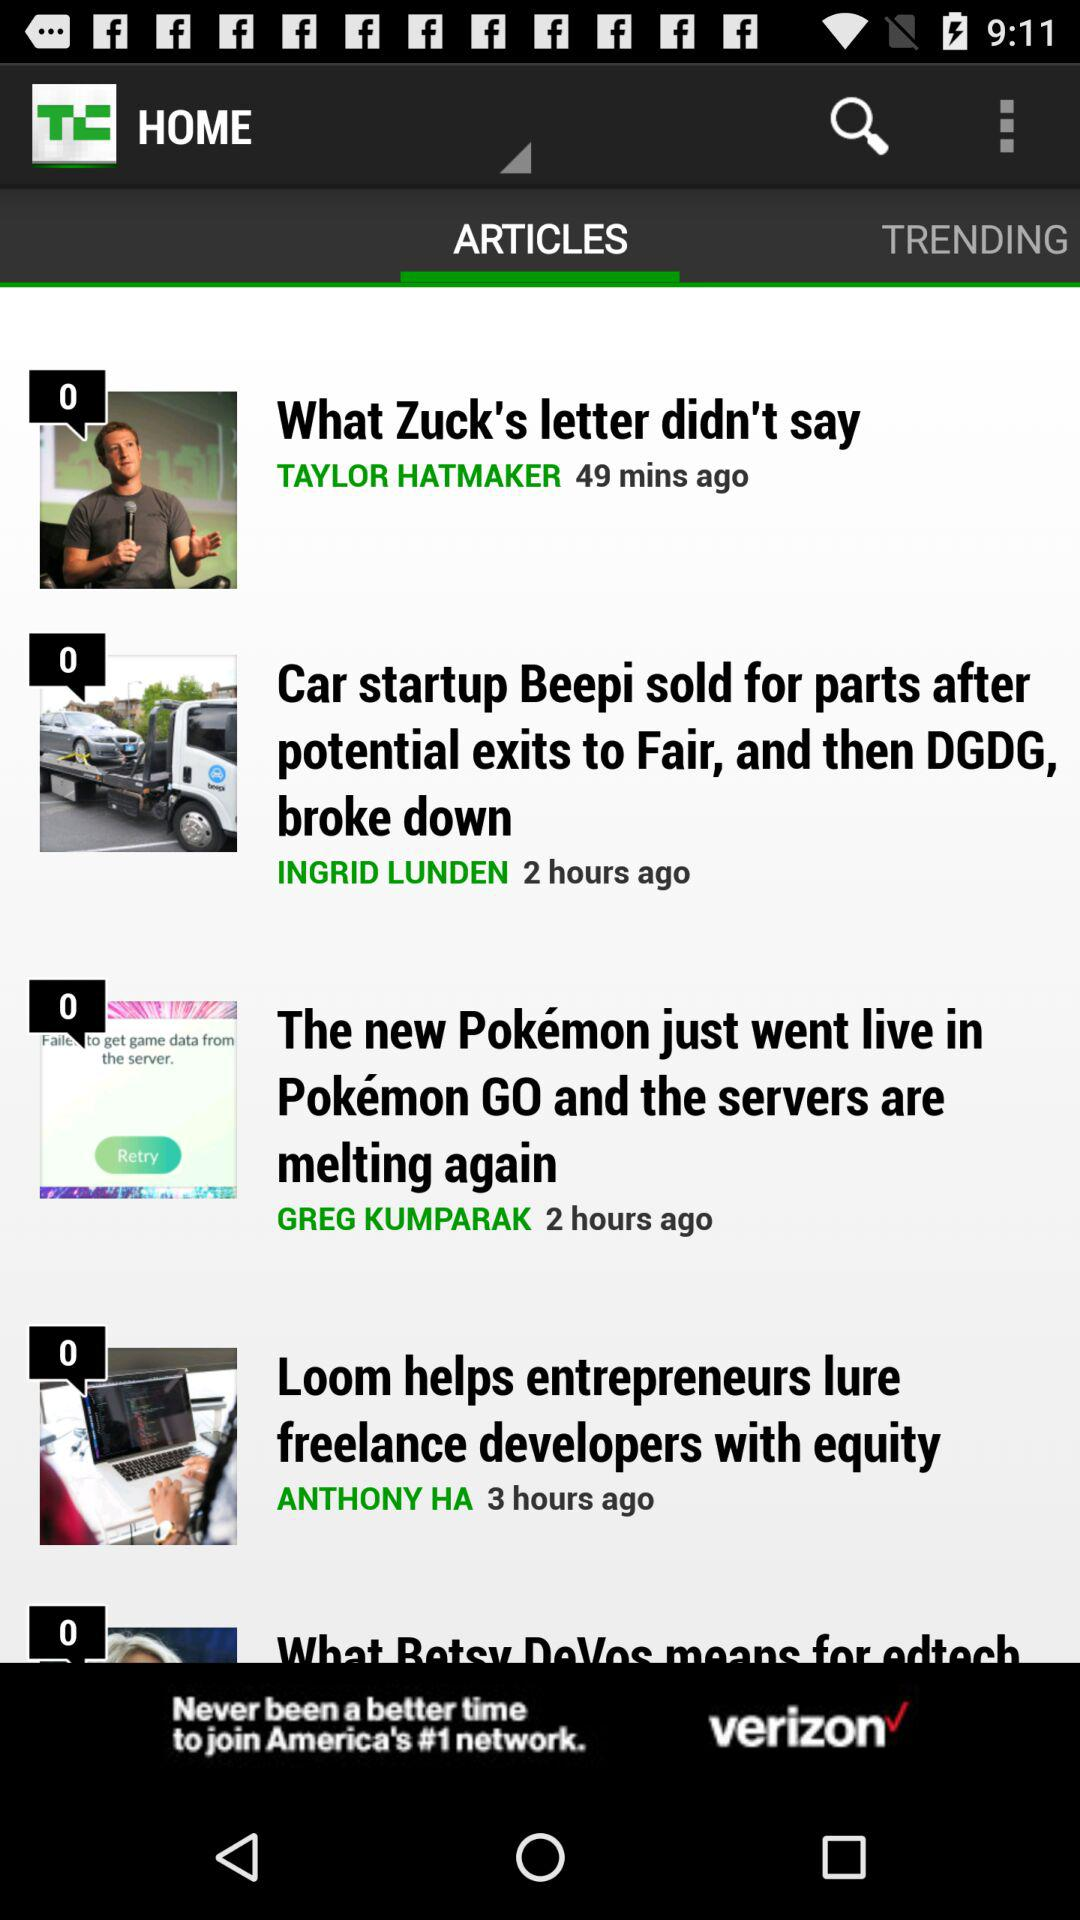How many minutes ago was the article "What Zuck's letter didn't say" published? The article "What Zuck's letter didn't say" was published 49 minutes ago. 